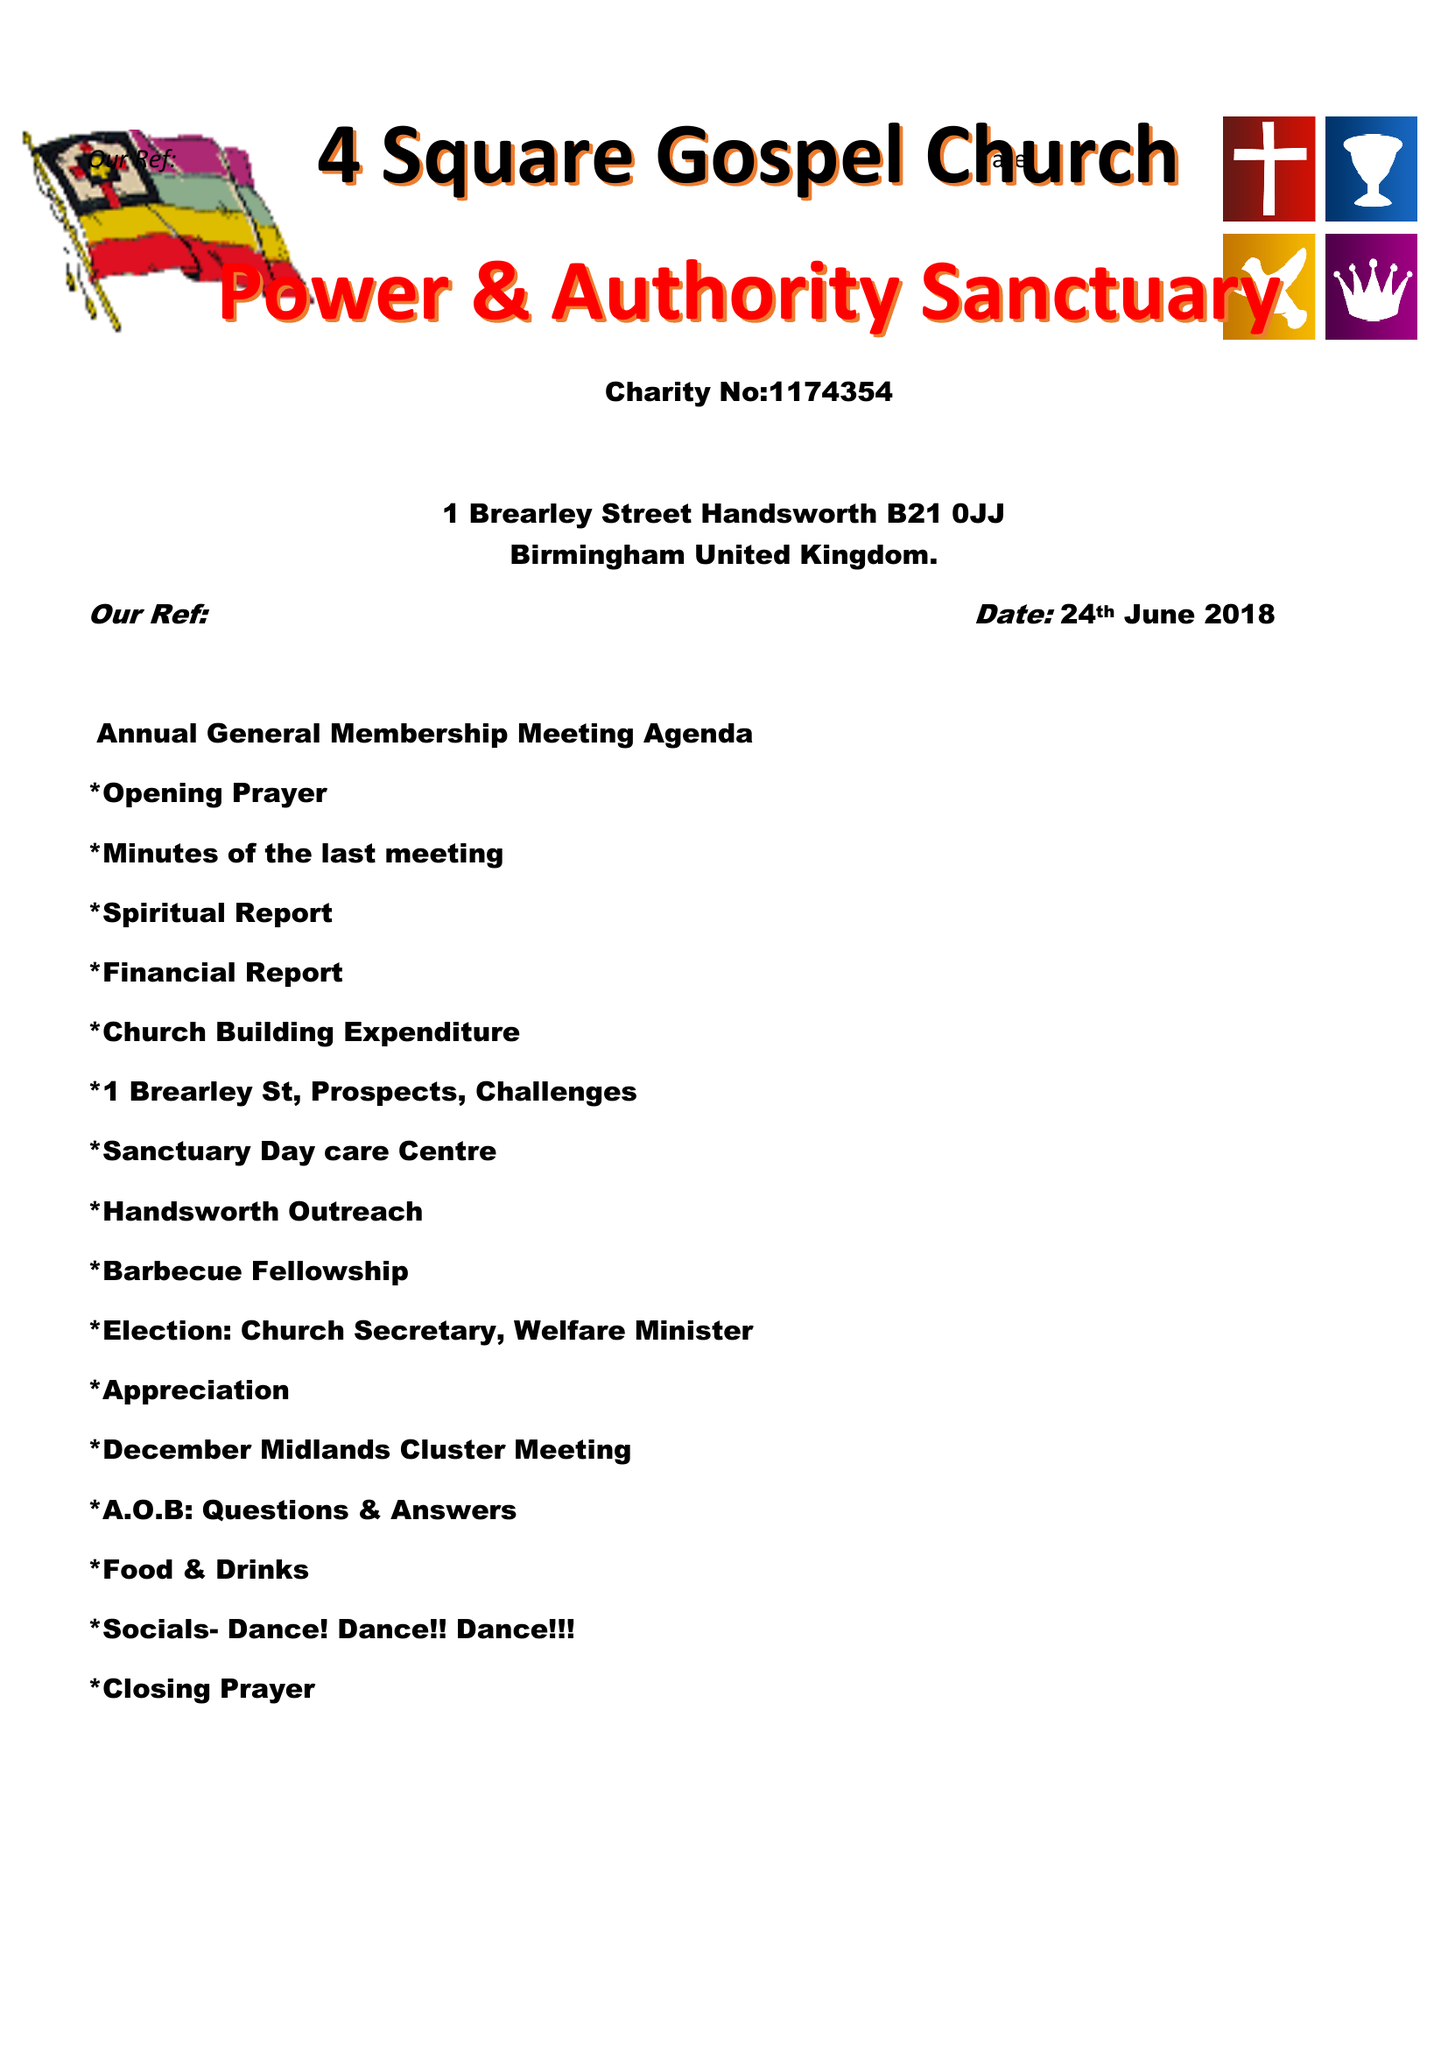What is the value for the address__post_town?
Answer the question using a single word or phrase. BIRMINGHAM 